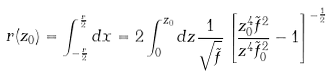Convert formula to latex. <formula><loc_0><loc_0><loc_500><loc_500>r ( z _ { 0 } ) = \int _ { - \frac { r } { 2 } } ^ { \frac { r } { 2 } } d x = 2 \int _ { 0 } ^ { z _ { 0 } } d z \frac { 1 } { \sqrt { \tilde { f } } } \left [ \frac { z _ { 0 } ^ { 4 } \tilde { f } ^ { 2 } } { z ^ { 4 } \tilde { f } _ { 0 } ^ { 2 } } - 1 \right ] ^ { - \frac { 1 } { 2 } }</formula> 